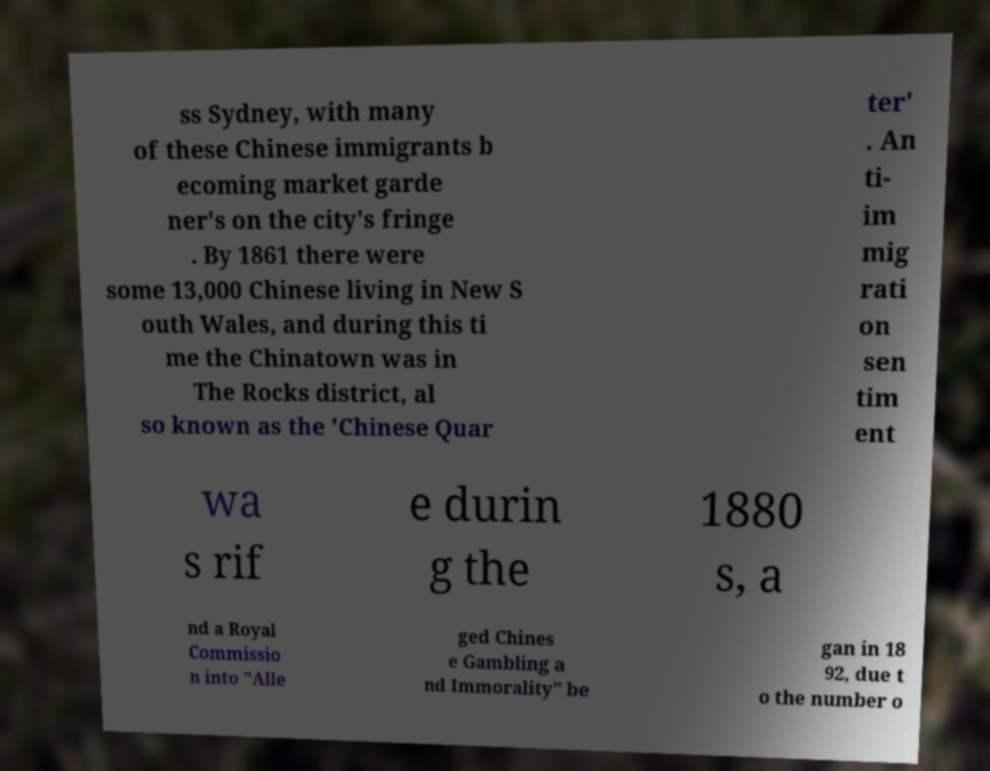Please identify and transcribe the text found in this image. ss Sydney, with many of these Chinese immigrants b ecoming market garde ner's on the city's fringe . By 1861 there were some 13,000 Chinese living in New S outh Wales, and during this ti me the Chinatown was in The Rocks district, al so known as the 'Chinese Quar ter' . An ti- im mig rati on sen tim ent wa s rif e durin g the 1880 s, a nd a Royal Commissio n into "Alle ged Chines e Gambling a nd Immorality" be gan in 18 92, due t o the number o 